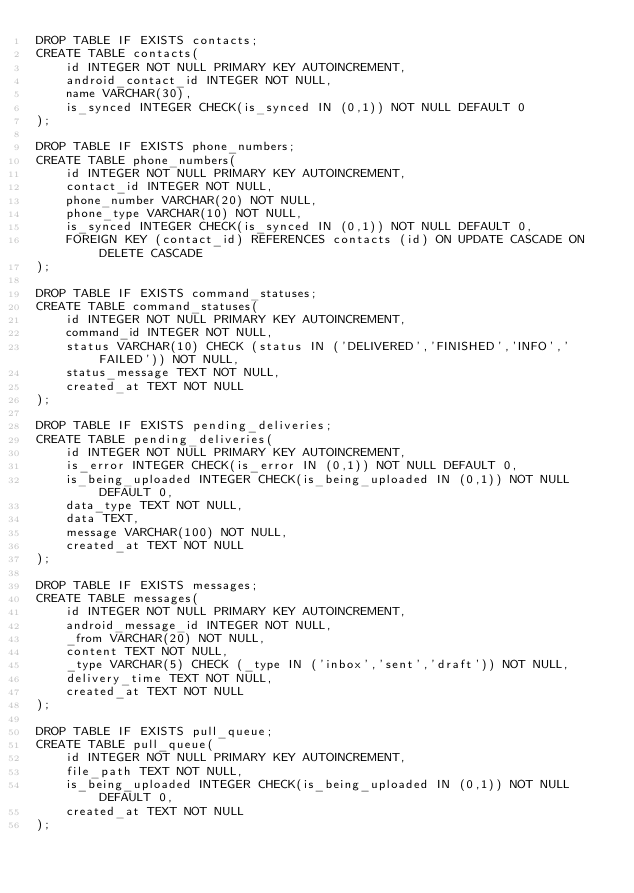Convert code to text. <code><loc_0><loc_0><loc_500><loc_500><_SQL_>DROP TABLE IF EXISTS contacts;
CREATE TABLE contacts(
	id INTEGER NOT NULL PRIMARY KEY AUTOINCREMENT,
	android_contact_id INTEGER NOT NULL,
	name VARCHAR(30),
	is_synced INTEGER CHECK(is_synced IN (0,1)) NOT NULL DEFAULT 0
);

DROP TABLE IF EXISTS phone_numbers;
CREATE TABLE phone_numbers(
	id INTEGER NOT NULL PRIMARY KEY AUTOINCREMENT,
	contact_id INTEGER NOT NULL,
	phone_number VARCHAR(20) NOT NULL,
	phone_type VARCHAR(10) NOT NULL,
	is_synced INTEGER CHECK(is_synced IN (0,1)) NOT NULL DEFAULT 0,
	FOREIGN KEY (contact_id) REFERENCES contacts (id) ON UPDATE CASCADE ON DELETE CASCADE
);

DROP TABLE IF EXISTS command_statuses;
CREATE TABLE command_statuses(
    id INTEGER NOT NULL PRIMARY KEY AUTOINCREMENT,
    command_id INTEGER NOT NULL,
    status VARCHAR(10) CHECK (status IN ('DELIVERED','FINISHED','INFO','FAILED')) NOT NULL,
    status_message TEXT NOT NULL,
    created_at TEXT NOT NULL
);

DROP TABLE IF EXISTS pending_deliveries;
CREATE TABLE pending_deliveries(
    id INTEGER NOT NULL PRIMARY KEY AUTOINCREMENT,
    is_error INTEGER CHECK(is_error IN (0,1)) NOT NULL DEFAULT 0,
    is_being_uploaded INTEGER CHECK(is_being_uploaded IN (0,1)) NOT NULL DEFAULT 0,
    data_type TEXT NOT NULL,
    data TEXT,
    message VARCHAR(100) NOT NULL,
    created_at TEXT NOT NULL
);

DROP TABLE IF EXISTS messages;
CREATE TABLE messages(
    id INTEGER NOT NULL PRIMARY KEY AUTOINCREMENT,
    android_message_id INTEGER NOT NULL,
    _from VARCHAR(20) NOT NULL,
    content TEXT NOT NULL,
    _type VARCHAR(5) CHECK (_type IN ('inbox','sent','draft')) NOT NULL,
    delivery_time TEXT NOT NULL,
    created_at TEXT NOT NULL
);

DROP TABLE IF EXISTS pull_queue;
CREATE TABLE pull_queue(
    id INTEGER NOT NULL PRIMARY KEY AUTOINCREMENT,
    file_path TEXT NOT NULL,
    is_being_uploaded INTEGER CHECK(is_being_uploaded IN (0,1)) NOT NULL DEFAULT 0,
    created_at TEXT NOT NULL
);
</code> 